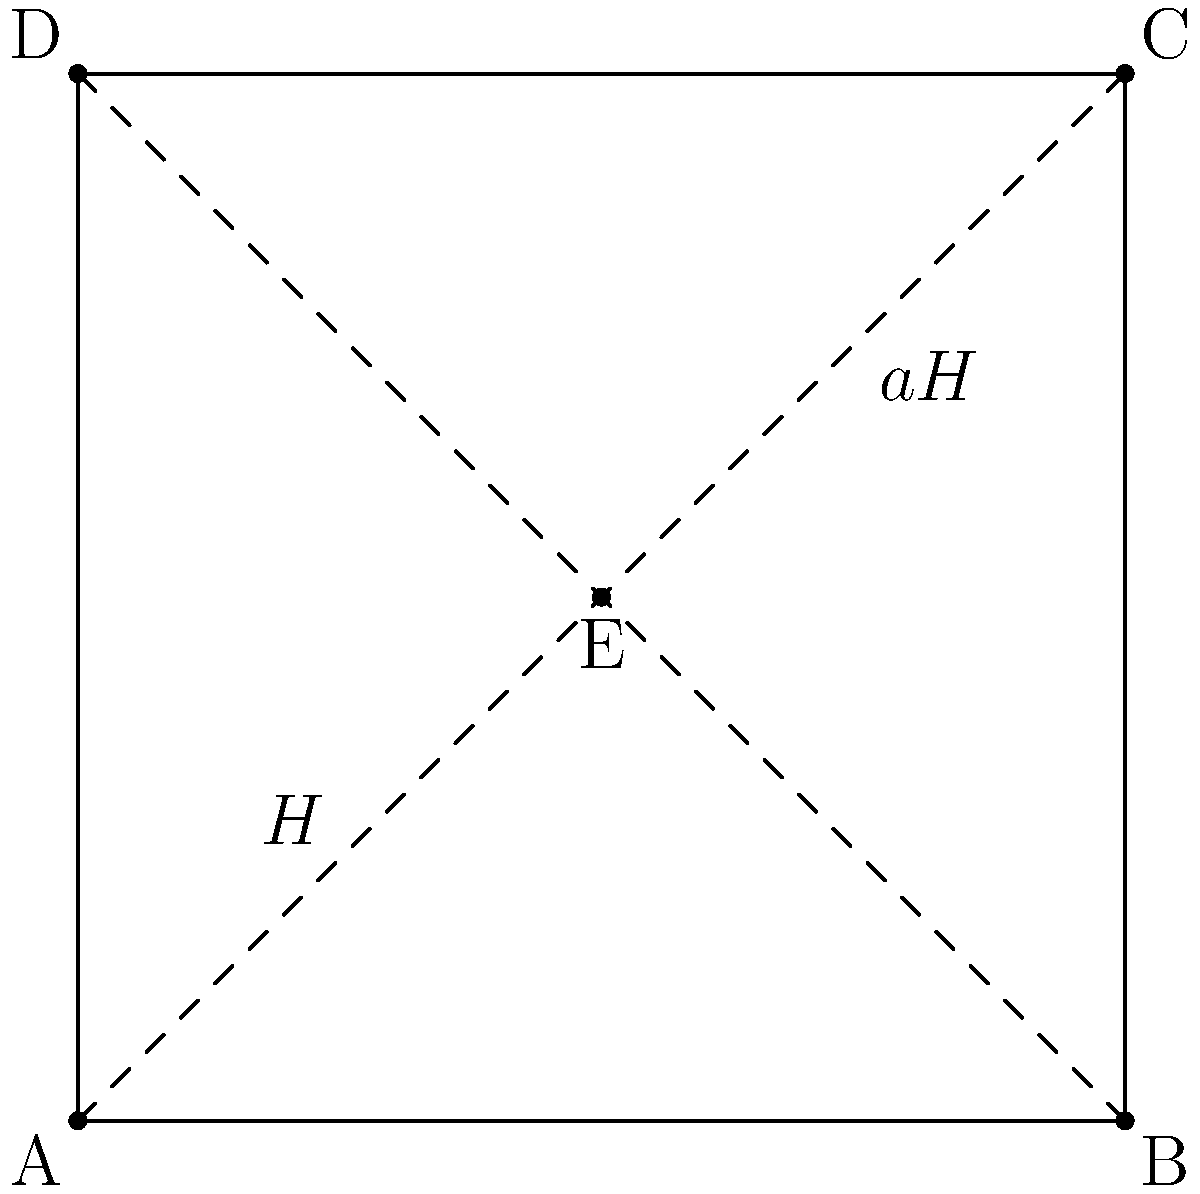In the context of group theory, the square ABCD represents a group G, and the triangle AED represents a subgroup H. The triangle BCE represents a coset aH. How would you explain the concept of cosets to your family at the dinner table using this geometric representation? To explain the concept of cosets to your family using this geometric representation, you could follow these steps:

1. Start by explaining that the entire square ABCD represents a group G, which is a set of elements with a special operation.

2. Point out that the triangle AED represents a subgroup H of G. This is like a smaller "club" within the larger group that follows the same rules.

3. Explain that a coset is formed when we "shift" or "translate" the subgroup H by an element 'a' that's not in H. In this case, the triangle BCE represents the coset aH.

4. Highlight that the coset aH (triangle BCE) has the same shape and size as the subgroup H (triangle AED). This illustrates an important property of cosets: they partition the group into equal-sized pieces.

5. Emphasize that every point in G belongs to exactly one coset of H. This is visually represented by how the two triangles (H and aH) cover the entire square without overlapping.

6. Draw an analogy to slicing a cake (the group G) into equal pieces (the cosets). Each slice (coset) contains the same amount of cake, just in a different position.

7. Conclude by noting that this geometric representation helps visualize how cosets divide a group into equal, non-overlapping subsets, which is crucial for understanding many group theory concepts and applications in mathematics and beyond.
Answer: Cosets are "shifted" versions of a subgroup that partition the group into equal, non-overlapping subsets. 